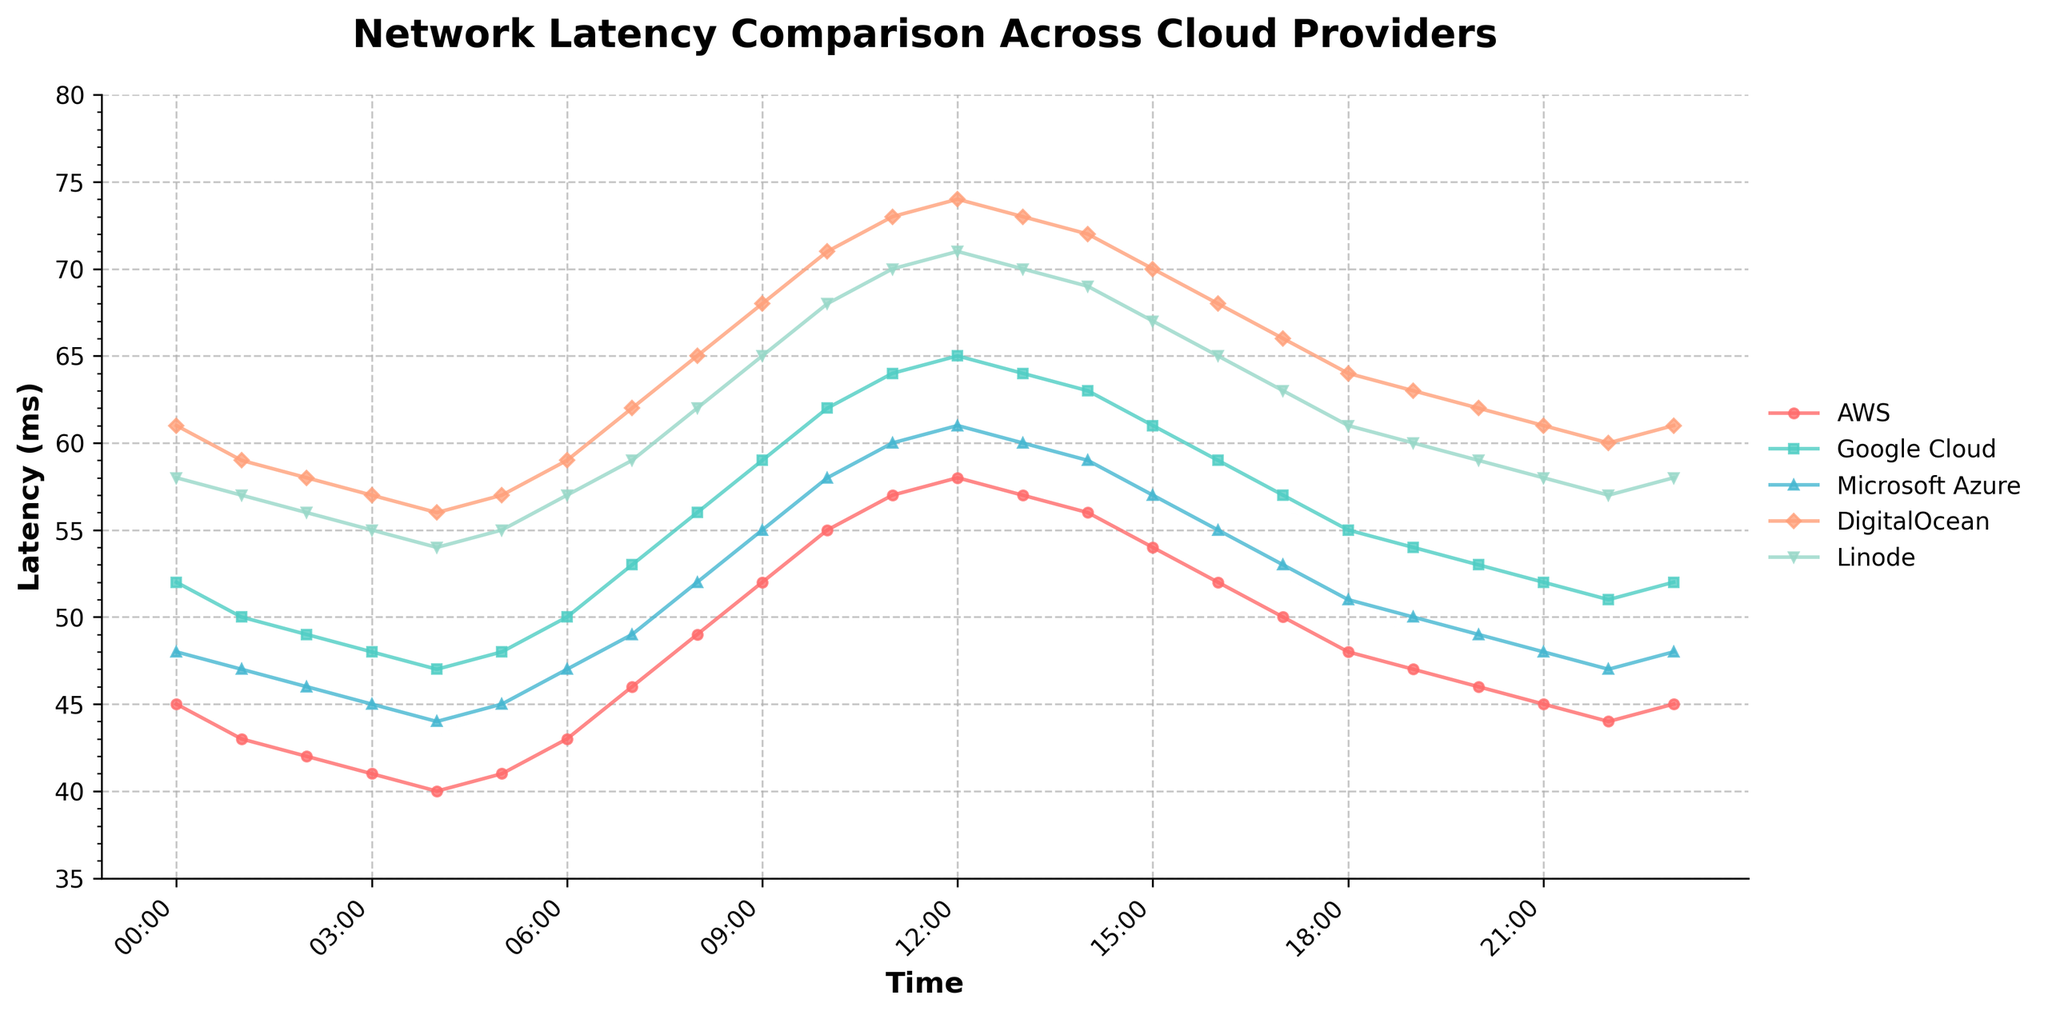Which cloud provider has the lowest latency at 00:00? At 00:00, AWS has a latency of 45ms, Google Cloud has 52ms, Microsoft Azure has 48ms, DigitalOcean has 61ms, and Linode has 58ms. The lowest latency is 45ms by AWS.
Answer: AWS During which time period does Google Cloud have the highest latency? Google Cloud's highest latency, 65ms, occurs at 12:00. Skim through the data points on the graph to identify when the peak occurs.
Answer: 12:00 Which cloud provider shows the most consistent latency over the 24-hour period? To determine consistency, observe the variation in latency over time. Linode has the smallest variation, ranging from 54ms to 71ms, indicating consistent performance.
Answer: Linode What is the combined latency of AWS and Google Cloud at 15:00? At 15:00, AWS has a latency of 54ms and Google Cloud has 61ms. Summing these values, 54 + 61 = 115.
Answer: 115ms Between 09:00 and 17:00, which cloud provider has the largest increase in latency? At 09:00, AWS has 52ms and at 17:00 it has 50ms; Google Cloud has 59ms and then 57ms; Microsoft Azure has 55ms and then 53ms; DigitalOcean has 68ms and then 66ms; Linode has 65ms and then 63ms. Calculate the differences: AWS (-2ms), Google Cloud (-2ms), Microsoft Azure (-2ms), DigitalOcean (-2ms), Linode (-2ms). They all have equal decreases.
Answer: No provider On average, which cloud provider has the highest latency? Calculate the average latency for each provider over the 24-hour period. Taking a cross-section of data points helps determine DigitalOcean generally has a higher latency, consistently in the range of 56-74ms.
Answer: DigitalOcean What is the visual difference in latency trends between AWS and DigitalOcean? AWS shows a more stable and consistent latency trend with minor fluctuations, whereas DigitalOcean’s latency significantly increases during business hours, peaking mid-day, and drops afterward.
Answer: AWS is stable; DigitalOcean peaks mid-day What is the difference in latency between the highest point for Google Cloud and the lowest point for Microsoft Azure? The highest latency for Google Cloud (65ms) occurs around 12:00. The lowest latency for Microsoft Azure (44ms) happens at 04:00. The difference is 65 - 44 = 21ms.
Answer: 21ms Which provider's latency does not drop below 60ms at any point? DigitalOcean's latency does not drop below 60ms at any data point shown in the graph.
Answer: DigitalOcean 